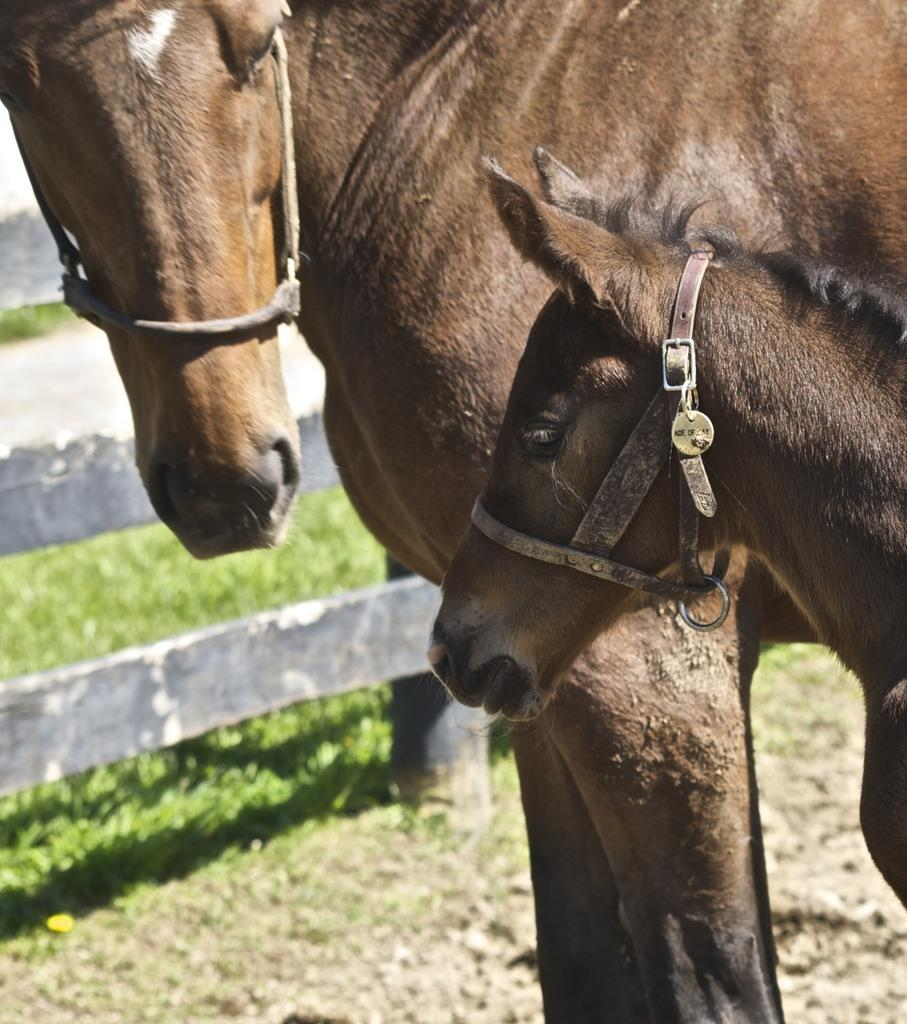How many horses are in the image? There are 2 brown horses in the image. What can be seen surrounding the horses? There is a fencing in the image. What type of terrain is visible in the image? There is grass visible in the image. What type of milk is being produced by the horses in the image? There is no indication of milk production in the image, as horses do not produce milk for human consumption. 